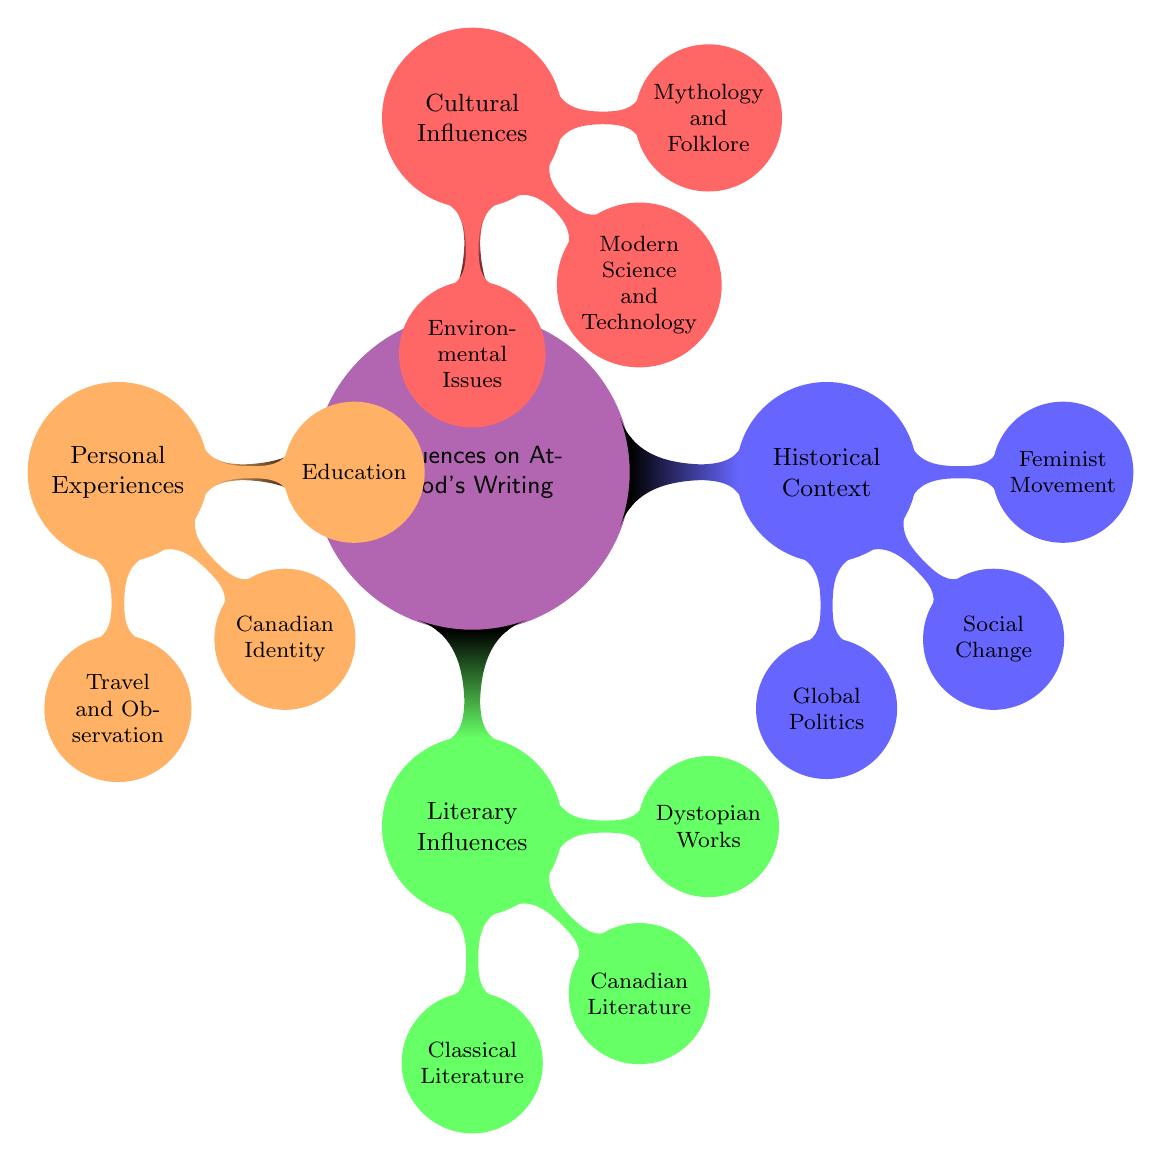What are the four main categories of influences on Atwood's writing? The diagram lists four main categories: Historical Context, Literary Influences, Personal Experiences, and Cultural Influences.
Answer: Historical Context, Literary Influences, Personal Experiences, Cultural Influences Which literary influence specifically relates to dystopian themes? The diagram identifies "Dystopian Works" under the category of Literary Influences. This includes works such as "1984" and "Brave New World."
Answer: Dystopian Works How many influences are listed under the Cultural Influences category? The Cultural Influences category contains three specific influences: Mythology and Folklore, Modern Science and Technology, and Environmental Issues.
Answer: 3 What personal experience relates to Atwood's education? The diagram mentions "Studied at Radcliffe College and Harvard University" under Personal Experiences. This directly relates to her educational background.
Answer: Studied at Radcliffe College and Harvard University Which major global event is associated with the Historical Context of Atwood's writing? The diagram points to "Cold War tensions" as a significant aspect of Global Politics, which is part of the Historical Context influences on her writing.
Answer: Cold War tensions Which Canadian author is listed as a literary influence? According to the diagram, "Alice Munro" is highlighted under Canadian Literature as an influence on Atwood's writing.
Answer: Alice Munro How are modern issues represented in Atwood's Cultural Influences? The diagram includes "Climate change awareness" as a specific aspect under Environmental Issues, showcasing how modern issues influence her work.
Answer: Climate change awareness What personal experience involves Atwood's identity? The diagram specifies "Grew up in Ontario, Canada" as part of the Personal Experiences category, directly relating to her identity.
Answer: Grew up in Ontario, Canada Which influence includes Greek mythology? Under Cultural Influences, the diagram shows "Mythology and Folklore," which includes Greek mythology as part of the influences.
Answer: Mythology and Folklore 